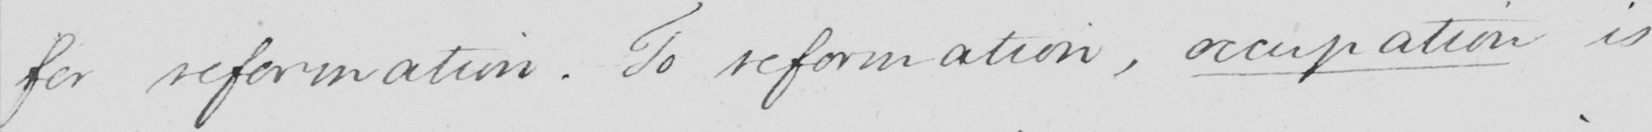What is written in this line of handwriting? for reformation . To reformation , occupation is 